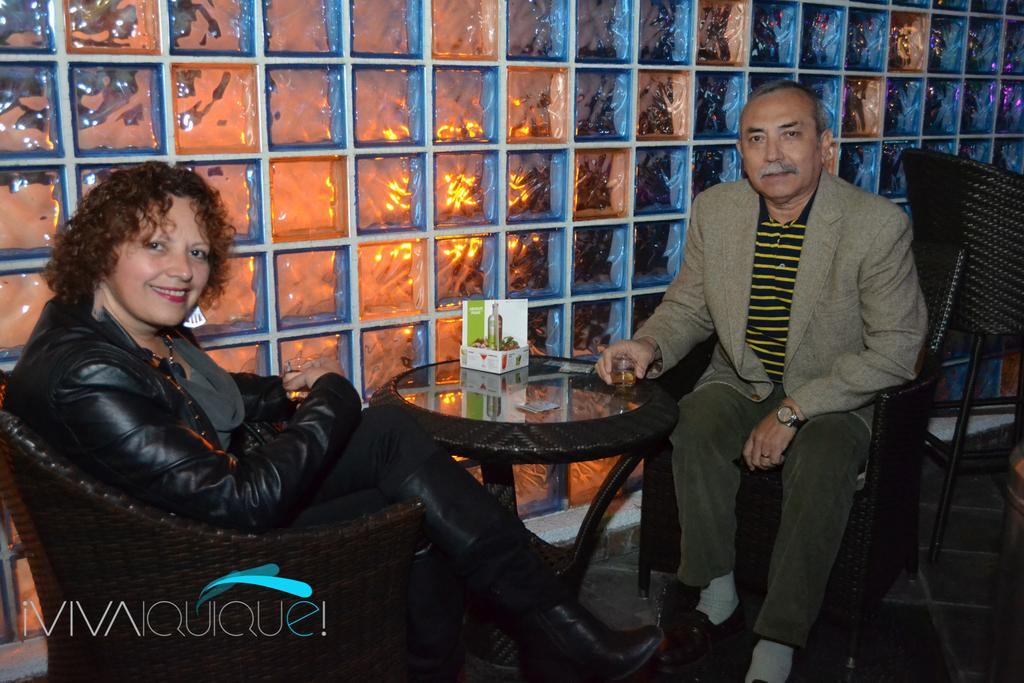Who is present in the image? There is a woman and a man in the image. What are the woman and man doing in the image? Both the woman and man are sitting on chairs. What is on the table in the image? There is a box on the table. What is visible in the background of the image? There is a wall in the image. What type of ink can be seen on the trail in the image? There is no trail or ink present in the image. 